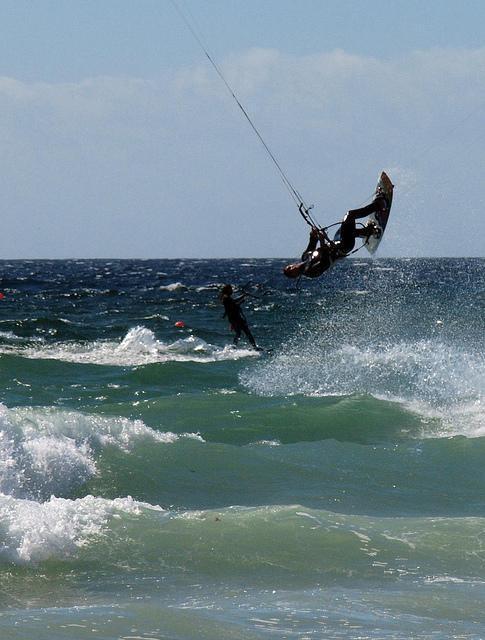How many horses are in the picture?
Give a very brief answer. 0. 